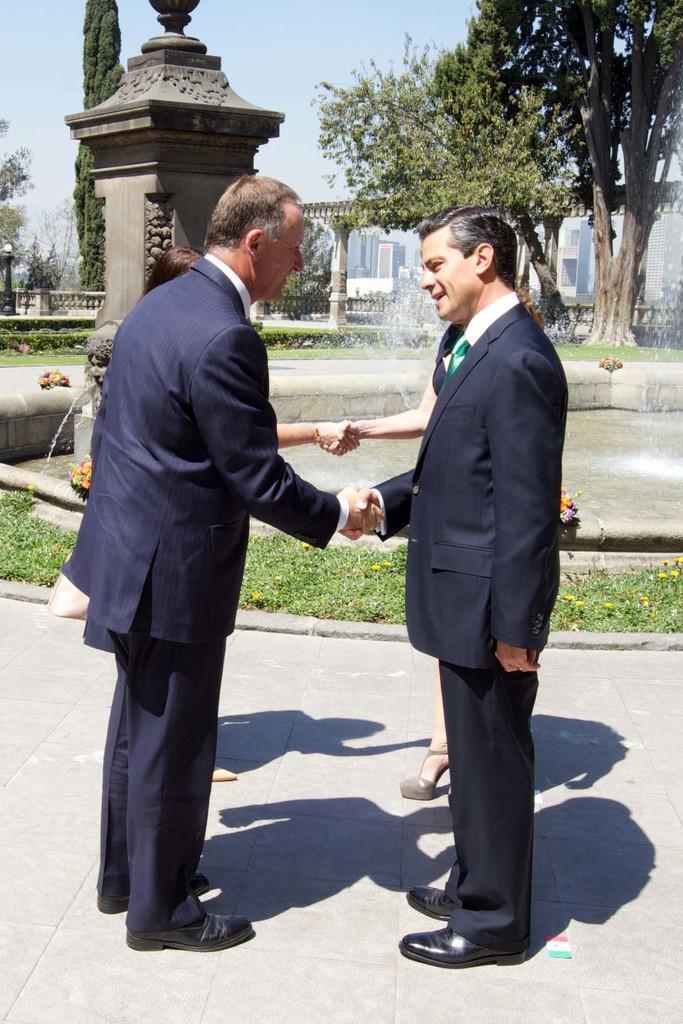Describe this image in one or two sentences. In this image we can see the buildings in the background, small walls, one pillar, one object looks like a monument, one fountain with water, some plants with flowers, some flowers near the fountain, one fence, one flag on the floor, some trees, bushes, plants and grass on the ground. At the top there is the sky. Two men standing and handshaking. Two women behind the men standing and handshaking. 